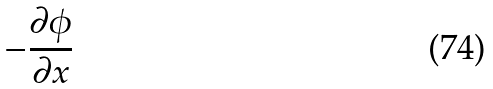<formula> <loc_0><loc_0><loc_500><loc_500>- \frac { \partial \phi } { \partial x }</formula> 